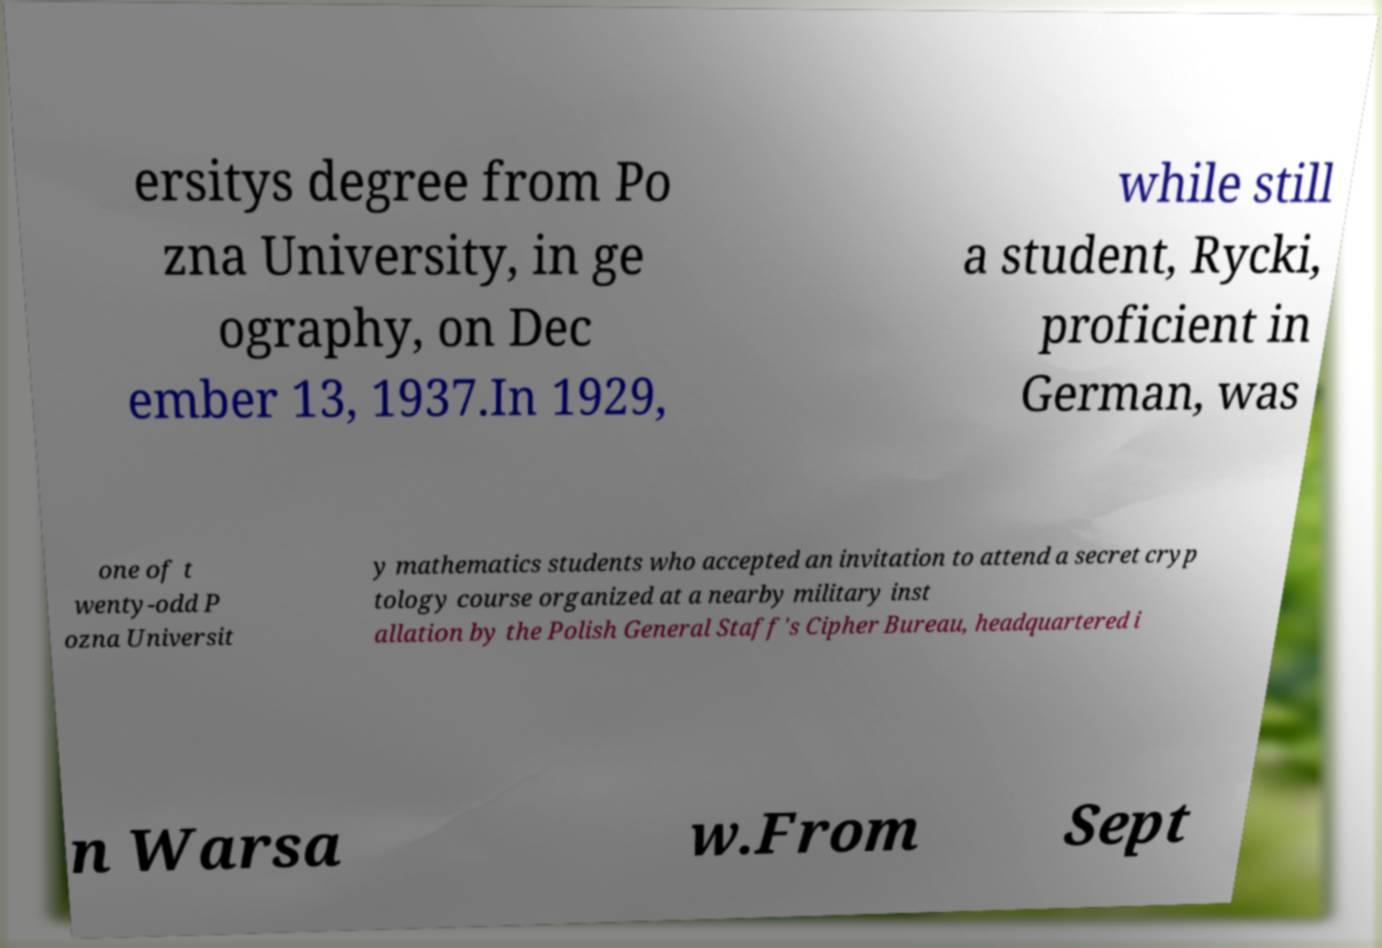Could you extract and type out the text from this image? ersitys degree from Po zna University, in ge ography, on Dec ember 13, 1937.In 1929, while still a student, Rycki, proficient in German, was one of t wenty-odd P ozna Universit y mathematics students who accepted an invitation to attend a secret cryp tology course organized at a nearby military inst allation by the Polish General Staff's Cipher Bureau, headquartered i n Warsa w.From Sept 